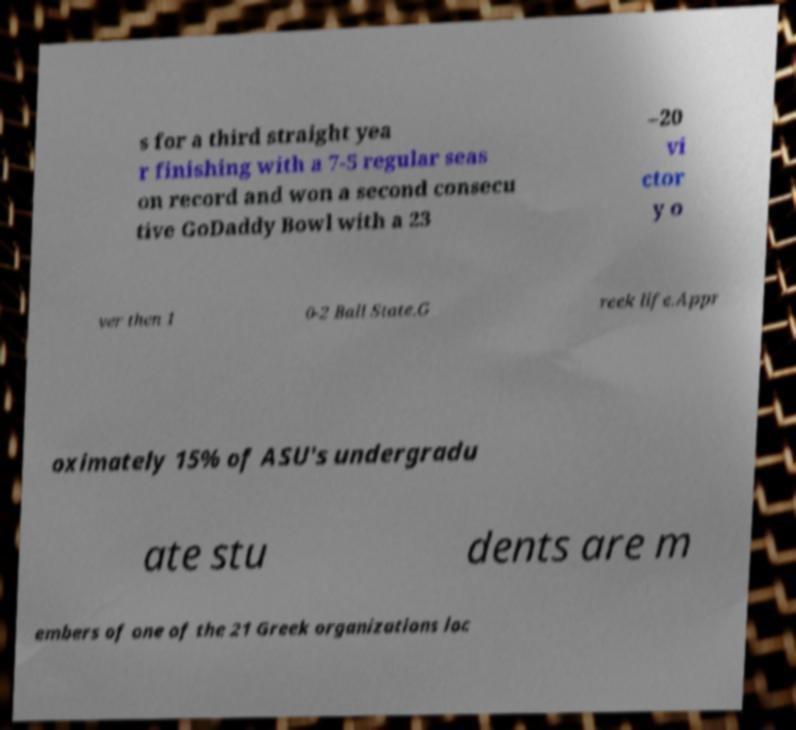Could you assist in decoding the text presented in this image and type it out clearly? s for a third straight yea r finishing with a 7-5 regular seas on record and won a second consecu tive GoDaddy Bowl with a 23 –20 vi ctor y o ver then 1 0-2 Ball State.G reek life.Appr oximately 15% of ASU's undergradu ate stu dents are m embers of one of the 21 Greek organizations loc 